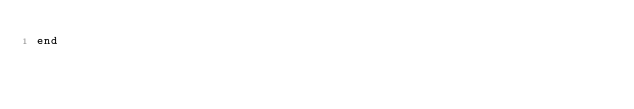<code> <loc_0><loc_0><loc_500><loc_500><_Ruby_>end
</code> 